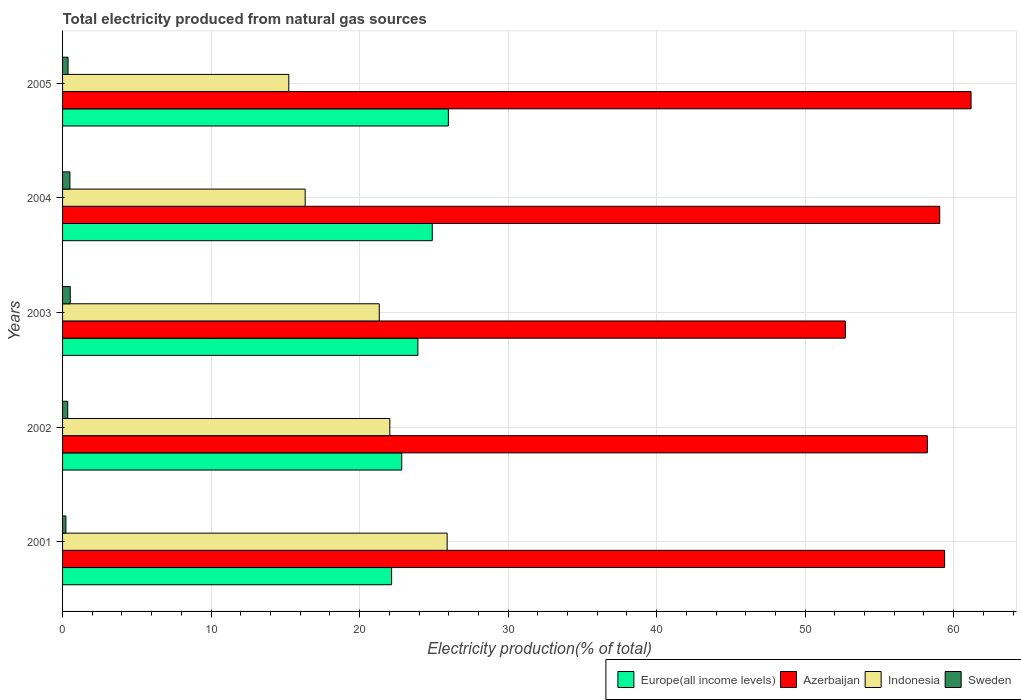How many groups of bars are there?
Give a very brief answer. 5. Are the number of bars on each tick of the Y-axis equal?
Your response must be concise. Yes. How many bars are there on the 1st tick from the top?
Your answer should be very brief. 4. How many bars are there on the 5th tick from the bottom?
Your answer should be compact. 4. In how many cases, is the number of bars for a given year not equal to the number of legend labels?
Give a very brief answer. 0. What is the total electricity produced in Europe(all income levels) in 2002?
Provide a succinct answer. 22.84. Across all years, what is the maximum total electricity produced in Sweden?
Your response must be concise. 0.52. Across all years, what is the minimum total electricity produced in Indonesia?
Make the answer very short. 15.23. What is the total total electricity produced in Europe(all income levels) in the graph?
Keep it short and to the point. 119.79. What is the difference between the total electricity produced in Indonesia in 2002 and that in 2005?
Ensure brevity in your answer.  6.8. What is the difference between the total electricity produced in Indonesia in 2004 and the total electricity produced in Europe(all income levels) in 2001?
Your answer should be very brief. -5.82. What is the average total electricity produced in Sweden per year?
Provide a short and direct response. 0.39. In the year 2003, what is the difference between the total electricity produced in Sweden and total electricity produced in Indonesia?
Offer a very short reply. -20.81. In how many years, is the total electricity produced in Indonesia greater than 40 %?
Make the answer very short. 0. What is the ratio of the total electricity produced in Sweden in 2002 to that in 2005?
Ensure brevity in your answer.  0.94. What is the difference between the highest and the second highest total electricity produced in Sweden?
Provide a succinct answer. 0.02. What is the difference between the highest and the lowest total electricity produced in Europe(all income levels)?
Ensure brevity in your answer.  3.82. In how many years, is the total electricity produced in Indonesia greater than the average total electricity produced in Indonesia taken over all years?
Your answer should be compact. 3. What does the 2nd bar from the top in 2004 represents?
Offer a very short reply. Indonesia. Are all the bars in the graph horizontal?
Ensure brevity in your answer.  Yes. Does the graph contain grids?
Keep it short and to the point. Yes. Where does the legend appear in the graph?
Keep it short and to the point. Bottom right. How many legend labels are there?
Provide a short and direct response. 4. What is the title of the graph?
Your response must be concise. Total electricity produced from natural gas sources. What is the Electricity production(% of total) in Europe(all income levels) in 2001?
Your response must be concise. 22.16. What is the Electricity production(% of total) of Azerbaijan in 2001?
Provide a short and direct response. 59.39. What is the Electricity production(% of total) in Indonesia in 2001?
Keep it short and to the point. 25.9. What is the Electricity production(% of total) of Sweden in 2001?
Provide a short and direct response. 0.22. What is the Electricity production(% of total) in Europe(all income levels) in 2002?
Your answer should be compact. 22.84. What is the Electricity production(% of total) of Azerbaijan in 2002?
Your answer should be compact. 58.23. What is the Electricity production(% of total) in Indonesia in 2002?
Your response must be concise. 22.03. What is the Electricity production(% of total) in Sweden in 2002?
Provide a short and direct response. 0.35. What is the Electricity production(% of total) of Europe(all income levels) in 2003?
Your answer should be compact. 23.92. What is the Electricity production(% of total) in Azerbaijan in 2003?
Give a very brief answer. 52.71. What is the Electricity production(% of total) of Indonesia in 2003?
Keep it short and to the point. 21.32. What is the Electricity production(% of total) of Sweden in 2003?
Make the answer very short. 0.52. What is the Electricity production(% of total) of Europe(all income levels) in 2004?
Make the answer very short. 24.89. What is the Electricity production(% of total) in Azerbaijan in 2004?
Keep it short and to the point. 59.06. What is the Electricity production(% of total) of Indonesia in 2004?
Offer a very short reply. 16.34. What is the Electricity production(% of total) in Sweden in 2004?
Keep it short and to the point. 0.49. What is the Electricity production(% of total) of Europe(all income levels) in 2005?
Keep it short and to the point. 25.98. What is the Electricity production(% of total) of Azerbaijan in 2005?
Provide a short and direct response. 61.17. What is the Electricity production(% of total) of Indonesia in 2005?
Keep it short and to the point. 15.23. What is the Electricity production(% of total) in Sweden in 2005?
Your answer should be compact. 0.37. Across all years, what is the maximum Electricity production(% of total) of Europe(all income levels)?
Offer a very short reply. 25.98. Across all years, what is the maximum Electricity production(% of total) in Azerbaijan?
Give a very brief answer. 61.17. Across all years, what is the maximum Electricity production(% of total) of Indonesia?
Ensure brevity in your answer.  25.9. Across all years, what is the maximum Electricity production(% of total) of Sweden?
Offer a very short reply. 0.52. Across all years, what is the minimum Electricity production(% of total) of Europe(all income levels)?
Your answer should be compact. 22.16. Across all years, what is the minimum Electricity production(% of total) of Azerbaijan?
Provide a short and direct response. 52.71. Across all years, what is the minimum Electricity production(% of total) of Indonesia?
Offer a terse response. 15.23. Across all years, what is the minimum Electricity production(% of total) in Sweden?
Give a very brief answer. 0.22. What is the total Electricity production(% of total) of Europe(all income levels) in the graph?
Offer a terse response. 119.79. What is the total Electricity production(% of total) in Azerbaijan in the graph?
Your answer should be compact. 290.55. What is the total Electricity production(% of total) of Indonesia in the graph?
Offer a very short reply. 100.82. What is the total Electricity production(% of total) of Sweden in the graph?
Keep it short and to the point. 1.95. What is the difference between the Electricity production(% of total) in Europe(all income levels) in 2001 and that in 2002?
Offer a very short reply. -0.68. What is the difference between the Electricity production(% of total) in Azerbaijan in 2001 and that in 2002?
Give a very brief answer. 1.16. What is the difference between the Electricity production(% of total) of Indonesia in 2001 and that in 2002?
Provide a short and direct response. 3.86. What is the difference between the Electricity production(% of total) of Sweden in 2001 and that in 2002?
Your response must be concise. -0.12. What is the difference between the Electricity production(% of total) of Europe(all income levels) in 2001 and that in 2003?
Offer a terse response. -1.77. What is the difference between the Electricity production(% of total) of Azerbaijan in 2001 and that in 2003?
Your answer should be very brief. 6.68. What is the difference between the Electricity production(% of total) of Indonesia in 2001 and that in 2003?
Your response must be concise. 4.57. What is the difference between the Electricity production(% of total) of Sweden in 2001 and that in 2003?
Provide a succinct answer. -0.29. What is the difference between the Electricity production(% of total) of Europe(all income levels) in 2001 and that in 2004?
Give a very brief answer. -2.74. What is the difference between the Electricity production(% of total) in Azerbaijan in 2001 and that in 2004?
Make the answer very short. 0.33. What is the difference between the Electricity production(% of total) in Indonesia in 2001 and that in 2004?
Provide a succinct answer. 9.56. What is the difference between the Electricity production(% of total) of Sweden in 2001 and that in 2004?
Offer a very short reply. -0.27. What is the difference between the Electricity production(% of total) of Europe(all income levels) in 2001 and that in 2005?
Offer a very short reply. -3.82. What is the difference between the Electricity production(% of total) of Azerbaijan in 2001 and that in 2005?
Provide a short and direct response. -1.78. What is the difference between the Electricity production(% of total) in Indonesia in 2001 and that in 2005?
Offer a terse response. 10.66. What is the difference between the Electricity production(% of total) of Sweden in 2001 and that in 2005?
Your answer should be compact. -0.15. What is the difference between the Electricity production(% of total) of Europe(all income levels) in 2002 and that in 2003?
Offer a very short reply. -1.09. What is the difference between the Electricity production(% of total) in Azerbaijan in 2002 and that in 2003?
Provide a short and direct response. 5.52. What is the difference between the Electricity production(% of total) in Indonesia in 2002 and that in 2003?
Your answer should be very brief. 0.71. What is the difference between the Electricity production(% of total) of Sweden in 2002 and that in 2003?
Offer a terse response. -0.17. What is the difference between the Electricity production(% of total) of Europe(all income levels) in 2002 and that in 2004?
Offer a very short reply. -2.05. What is the difference between the Electricity production(% of total) in Azerbaijan in 2002 and that in 2004?
Offer a very short reply. -0.83. What is the difference between the Electricity production(% of total) of Indonesia in 2002 and that in 2004?
Your answer should be very brief. 5.7. What is the difference between the Electricity production(% of total) in Sweden in 2002 and that in 2004?
Your answer should be compact. -0.15. What is the difference between the Electricity production(% of total) in Europe(all income levels) in 2002 and that in 2005?
Your answer should be compact. -3.14. What is the difference between the Electricity production(% of total) in Azerbaijan in 2002 and that in 2005?
Give a very brief answer. -2.94. What is the difference between the Electricity production(% of total) of Indonesia in 2002 and that in 2005?
Ensure brevity in your answer.  6.8. What is the difference between the Electricity production(% of total) in Sweden in 2002 and that in 2005?
Give a very brief answer. -0.02. What is the difference between the Electricity production(% of total) of Europe(all income levels) in 2003 and that in 2004?
Give a very brief answer. -0.97. What is the difference between the Electricity production(% of total) of Azerbaijan in 2003 and that in 2004?
Your answer should be compact. -6.35. What is the difference between the Electricity production(% of total) in Indonesia in 2003 and that in 2004?
Provide a succinct answer. 4.99. What is the difference between the Electricity production(% of total) in Sweden in 2003 and that in 2004?
Give a very brief answer. 0.02. What is the difference between the Electricity production(% of total) in Europe(all income levels) in 2003 and that in 2005?
Provide a short and direct response. -2.05. What is the difference between the Electricity production(% of total) in Azerbaijan in 2003 and that in 2005?
Your answer should be very brief. -8.46. What is the difference between the Electricity production(% of total) in Indonesia in 2003 and that in 2005?
Offer a terse response. 6.09. What is the difference between the Electricity production(% of total) in Sweden in 2003 and that in 2005?
Offer a very short reply. 0.15. What is the difference between the Electricity production(% of total) of Europe(all income levels) in 2004 and that in 2005?
Ensure brevity in your answer.  -1.08. What is the difference between the Electricity production(% of total) in Azerbaijan in 2004 and that in 2005?
Your answer should be compact. -2.11. What is the difference between the Electricity production(% of total) in Indonesia in 2004 and that in 2005?
Keep it short and to the point. 1.1. What is the difference between the Electricity production(% of total) of Sweden in 2004 and that in 2005?
Make the answer very short. 0.12. What is the difference between the Electricity production(% of total) of Europe(all income levels) in 2001 and the Electricity production(% of total) of Azerbaijan in 2002?
Your answer should be compact. -36.07. What is the difference between the Electricity production(% of total) in Europe(all income levels) in 2001 and the Electricity production(% of total) in Indonesia in 2002?
Your response must be concise. 0.12. What is the difference between the Electricity production(% of total) in Europe(all income levels) in 2001 and the Electricity production(% of total) in Sweden in 2002?
Offer a terse response. 21.81. What is the difference between the Electricity production(% of total) in Azerbaijan in 2001 and the Electricity production(% of total) in Indonesia in 2002?
Ensure brevity in your answer.  37.35. What is the difference between the Electricity production(% of total) of Azerbaijan in 2001 and the Electricity production(% of total) of Sweden in 2002?
Provide a succinct answer. 59.04. What is the difference between the Electricity production(% of total) in Indonesia in 2001 and the Electricity production(% of total) in Sweden in 2002?
Provide a succinct answer. 25.55. What is the difference between the Electricity production(% of total) of Europe(all income levels) in 2001 and the Electricity production(% of total) of Azerbaijan in 2003?
Ensure brevity in your answer.  -30.55. What is the difference between the Electricity production(% of total) in Europe(all income levels) in 2001 and the Electricity production(% of total) in Indonesia in 2003?
Keep it short and to the point. 0.83. What is the difference between the Electricity production(% of total) in Europe(all income levels) in 2001 and the Electricity production(% of total) in Sweden in 2003?
Make the answer very short. 21.64. What is the difference between the Electricity production(% of total) of Azerbaijan in 2001 and the Electricity production(% of total) of Indonesia in 2003?
Provide a short and direct response. 38.06. What is the difference between the Electricity production(% of total) in Azerbaijan in 2001 and the Electricity production(% of total) in Sweden in 2003?
Provide a short and direct response. 58.87. What is the difference between the Electricity production(% of total) of Indonesia in 2001 and the Electricity production(% of total) of Sweden in 2003?
Provide a short and direct response. 25.38. What is the difference between the Electricity production(% of total) of Europe(all income levels) in 2001 and the Electricity production(% of total) of Azerbaijan in 2004?
Your response must be concise. -36.9. What is the difference between the Electricity production(% of total) in Europe(all income levels) in 2001 and the Electricity production(% of total) in Indonesia in 2004?
Your response must be concise. 5.82. What is the difference between the Electricity production(% of total) in Europe(all income levels) in 2001 and the Electricity production(% of total) in Sweden in 2004?
Offer a very short reply. 21.66. What is the difference between the Electricity production(% of total) of Azerbaijan in 2001 and the Electricity production(% of total) of Indonesia in 2004?
Make the answer very short. 43.05. What is the difference between the Electricity production(% of total) in Azerbaijan in 2001 and the Electricity production(% of total) in Sweden in 2004?
Provide a short and direct response. 58.89. What is the difference between the Electricity production(% of total) of Indonesia in 2001 and the Electricity production(% of total) of Sweden in 2004?
Provide a short and direct response. 25.4. What is the difference between the Electricity production(% of total) in Europe(all income levels) in 2001 and the Electricity production(% of total) in Azerbaijan in 2005?
Keep it short and to the point. -39.02. What is the difference between the Electricity production(% of total) in Europe(all income levels) in 2001 and the Electricity production(% of total) in Indonesia in 2005?
Your answer should be very brief. 6.92. What is the difference between the Electricity production(% of total) in Europe(all income levels) in 2001 and the Electricity production(% of total) in Sweden in 2005?
Your answer should be compact. 21.79. What is the difference between the Electricity production(% of total) of Azerbaijan in 2001 and the Electricity production(% of total) of Indonesia in 2005?
Give a very brief answer. 44.16. What is the difference between the Electricity production(% of total) in Azerbaijan in 2001 and the Electricity production(% of total) in Sweden in 2005?
Keep it short and to the point. 59.02. What is the difference between the Electricity production(% of total) of Indonesia in 2001 and the Electricity production(% of total) of Sweden in 2005?
Provide a short and direct response. 25.53. What is the difference between the Electricity production(% of total) of Europe(all income levels) in 2002 and the Electricity production(% of total) of Azerbaijan in 2003?
Your answer should be very brief. -29.87. What is the difference between the Electricity production(% of total) of Europe(all income levels) in 2002 and the Electricity production(% of total) of Indonesia in 2003?
Your answer should be very brief. 1.51. What is the difference between the Electricity production(% of total) of Europe(all income levels) in 2002 and the Electricity production(% of total) of Sweden in 2003?
Your answer should be compact. 22.32. What is the difference between the Electricity production(% of total) of Azerbaijan in 2002 and the Electricity production(% of total) of Indonesia in 2003?
Provide a succinct answer. 36.9. What is the difference between the Electricity production(% of total) of Azerbaijan in 2002 and the Electricity production(% of total) of Sweden in 2003?
Keep it short and to the point. 57.71. What is the difference between the Electricity production(% of total) of Indonesia in 2002 and the Electricity production(% of total) of Sweden in 2003?
Offer a terse response. 21.52. What is the difference between the Electricity production(% of total) of Europe(all income levels) in 2002 and the Electricity production(% of total) of Azerbaijan in 2004?
Offer a very short reply. -36.22. What is the difference between the Electricity production(% of total) in Europe(all income levels) in 2002 and the Electricity production(% of total) in Indonesia in 2004?
Make the answer very short. 6.5. What is the difference between the Electricity production(% of total) in Europe(all income levels) in 2002 and the Electricity production(% of total) in Sweden in 2004?
Your answer should be compact. 22.34. What is the difference between the Electricity production(% of total) in Azerbaijan in 2002 and the Electricity production(% of total) in Indonesia in 2004?
Your answer should be very brief. 41.89. What is the difference between the Electricity production(% of total) in Azerbaijan in 2002 and the Electricity production(% of total) in Sweden in 2004?
Ensure brevity in your answer.  57.73. What is the difference between the Electricity production(% of total) in Indonesia in 2002 and the Electricity production(% of total) in Sweden in 2004?
Make the answer very short. 21.54. What is the difference between the Electricity production(% of total) in Europe(all income levels) in 2002 and the Electricity production(% of total) in Azerbaijan in 2005?
Keep it short and to the point. -38.33. What is the difference between the Electricity production(% of total) of Europe(all income levels) in 2002 and the Electricity production(% of total) of Indonesia in 2005?
Ensure brevity in your answer.  7.6. What is the difference between the Electricity production(% of total) in Europe(all income levels) in 2002 and the Electricity production(% of total) in Sweden in 2005?
Make the answer very short. 22.47. What is the difference between the Electricity production(% of total) of Azerbaijan in 2002 and the Electricity production(% of total) of Indonesia in 2005?
Your response must be concise. 42.99. What is the difference between the Electricity production(% of total) in Azerbaijan in 2002 and the Electricity production(% of total) in Sweden in 2005?
Make the answer very short. 57.86. What is the difference between the Electricity production(% of total) in Indonesia in 2002 and the Electricity production(% of total) in Sweden in 2005?
Offer a terse response. 21.66. What is the difference between the Electricity production(% of total) in Europe(all income levels) in 2003 and the Electricity production(% of total) in Azerbaijan in 2004?
Ensure brevity in your answer.  -35.14. What is the difference between the Electricity production(% of total) in Europe(all income levels) in 2003 and the Electricity production(% of total) in Indonesia in 2004?
Give a very brief answer. 7.59. What is the difference between the Electricity production(% of total) in Europe(all income levels) in 2003 and the Electricity production(% of total) in Sweden in 2004?
Ensure brevity in your answer.  23.43. What is the difference between the Electricity production(% of total) in Azerbaijan in 2003 and the Electricity production(% of total) in Indonesia in 2004?
Make the answer very short. 36.37. What is the difference between the Electricity production(% of total) of Azerbaijan in 2003 and the Electricity production(% of total) of Sweden in 2004?
Ensure brevity in your answer.  52.21. What is the difference between the Electricity production(% of total) in Indonesia in 2003 and the Electricity production(% of total) in Sweden in 2004?
Make the answer very short. 20.83. What is the difference between the Electricity production(% of total) in Europe(all income levels) in 2003 and the Electricity production(% of total) in Azerbaijan in 2005?
Keep it short and to the point. -37.25. What is the difference between the Electricity production(% of total) in Europe(all income levels) in 2003 and the Electricity production(% of total) in Indonesia in 2005?
Offer a terse response. 8.69. What is the difference between the Electricity production(% of total) in Europe(all income levels) in 2003 and the Electricity production(% of total) in Sweden in 2005?
Offer a terse response. 23.55. What is the difference between the Electricity production(% of total) in Azerbaijan in 2003 and the Electricity production(% of total) in Indonesia in 2005?
Ensure brevity in your answer.  37.47. What is the difference between the Electricity production(% of total) in Azerbaijan in 2003 and the Electricity production(% of total) in Sweden in 2005?
Give a very brief answer. 52.34. What is the difference between the Electricity production(% of total) of Indonesia in 2003 and the Electricity production(% of total) of Sweden in 2005?
Your response must be concise. 20.95. What is the difference between the Electricity production(% of total) in Europe(all income levels) in 2004 and the Electricity production(% of total) in Azerbaijan in 2005?
Give a very brief answer. -36.28. What is the difference between the Electricity production(% of total) of Europe(all income levels) in 2004 and the Electricity production(% of total) of Indonesia in 2005?
Offer a terse response. 9.66. What is the difference between the Electricity production(% of total) of Europe(all income levels) in 2004 and the Electricity production(% of total) of Sweden in 2005?
Your answer should be very brief. 24.52. What is the difference between the Electricity production(% of total) of Azerbaijan in 2004 and the Electricity production(% of total) of Indonesia in 2005?
Offer a terse response. 43.83. What is the difference between the Electricity production(% of total) in Azerbaijan in 2004 and the Electricity production(% of total) in Sweden in 2005?
Keep it short and to the point. 58.69. What is the difference between the Electricity production(% of total) of Indonesia in 2004 and the Electricity production(% of total) of Sweden in 2005?
Give a very brief answer. 15.97. What is the average Electricity production(% of total) in Europe(all income levels) per year?
Offer a very short reply. 23.96. What is the average Electricity production(% of total) of Azerbaijan per year?
Keep it short and to the point. 58.11. What is the average Electricity production(% of total) of Indonesia per year?
Provide a short and direct response. 20.16. What is the average Electricity production(% of total) of Sweden per year?
Provide a succinct answer. 0.39. In the year 2001, what is the difference between the Electricity production(% of total) in Europe(all income levels) and Electricity production(% of total) in Azerbaijan?
Make the answer very short. -37.23. In the year 2001, what is the difference between the Electricity production(% of total) of Europe(all income levels) and Electricity production(% of total) of Indonesia?
Your response must be concise. -3.74. In the year 2001, what is the difference between the Electricity production(% of total) of Europe(all income levels) and Electricity production(% of total) of Sweden?
Ensure brevity in your answer.  21.93. In the year 2001, what is the difference between the Electricity production(% of total) of Azerbaijan and Electricity production(% of total) of Indonesia?
Make the answer very short. 33.49. In the year 2001, what is the difference between the Electricity production(% of total) of Azerbaijan and Electricity production(% of total) of Sweden?
Provide a succinct answer. 59.17. In the year 2001, what is the difference between the Electricity production(% of total) of Indonesia and Electricity production(% of total) of Sweden?
Ensure brevity in your answer.  25.67. In the year 2002, what is the difference between the Electricity production(% of total) of Europe(all income levels) and Electricity production(% of total) of Azerbaijan?
Offer a very short reply. -35.39. In the year 2002, what is the difference between the Electricity production(% of total) in Europe(all income levels) and Electricity production(% of total) in Indonesia?
Offer a terse response. 0.8. In the year 2002, what is the difference between the Electricity production(% of total) of Europe(all income levels) and Electricity production(% of total) of Sweden?
Your answer should be very brief. 22.49. In the year 2002, what is the difference between the Electricity production(% of total) in Azerbaijan and Electricity production(% of total) in Indonesia?
Make the answer very short. 36.19. In the year 2002, what is the difference between the Electricity production(% of total) of Azerbaijan and Electricity production(% of total) of Sweden?
Your response must be concise. 57.88. In the year 2002, what is the difference between the Electricity production(% of total) of Indonesia and Electricity production(% of total) of Sweden?
Your response must be concise. 21.69. In the year 2003, what is the difference between the Electricity production(% of total) in Europe(all income levels) and Electricity production(% of total) in Azerbaijan?
Provide a short and direct response. -28.78. In the year 2003, what is the difference between the Electricity production(% of total) in Europe(all income levels) and Electricity production(% of total) in Indonesia?
Keep it short and to the point. 2.6. In the year 2003, what is the difference between the Electricity production(% of total) of Europe(all income levels) and Electricity production(% of total) of Sweden?
Ensure brevity in your answer.  23.41. In the year 2003, what is the difference between the Electricity production(% of total) in Azerbaijan and Electricity production(% of total) in Indonesia?
Keep it short and to the point. 31.38. In the year 2003, what is the difference between the Electricity production(% of total) of Azerbaijan and Electricity production(% of total) of Sweden?
Provide a succinct answer. 52.19. In the year 2003, what is the difference between the Electricity production(% of total) of Indonesia and Electricity production(% of total) of Sweden?
Make the answer very short. 20.81. In the year 2004, what is the difference between the Electricity production(% of total) in Europe(all income levels) and Electricity production(% of total) in Azerbaijan?
Your answer should be compact. -34.17. In the year 2004, what is the difference between the Electricity production(% of total) of Europe(all income levels) and Electricity production(% of total) of Indonesia?
Your answer should be very brief. 8.56. In the year 2004, what is the difference between the Electricity production(% of total) in Europe(all income levels) and Electricity production(% of total) in Sweden?
Offer a terse response. 24.4. In the year 2004, what is the difference between the Electricity production(% of total) of Azerbaijan and Electricity production(% of total) of Indonesia?
Give a very brief answer. 42.72. In the year 2004, what is the difference between the Electricity production(% of total) of Azerbaijan and Electricity production(% of total) of Sweden?
Give a very brief answer. 58.57. In the year 2004, what is the difference between the Electricity production(% of total) of Indonesia and Electricity production(% of total) of Sweden?
Provide a short and direct response. 15.84. In the year 2005, what is the difference between the Electricity production(% of total) in Europe(all income levels) and Electricity production(% of total) in Azerbaijan?
Make the answer very short. -35.19. In the year 2005, what is the difference between the Electricity production(% of total) of Europe(all income levels) and Electricity production(% of total) of Indonesia?
Make the answer very short. 10.74. In the year 2005, what is the difference between the Electricity production(% of total) of Europe(all income levels) and Electricity production(% of total) of Sweden?
Offer a terse response. 25.61. In the year 2005, what is the difference between the Electricity production(% of total) in Azerbaijan and Electricity production(% of total) in Indonesia?
Give a very brief answer. 45.94. In the year 2005, what is the difference between the Electricity production(% of total) in Azerbaijan and Electricity production(% of total) in Sweden?
Offer a terse response. 60.8. In the year 2005, what is the difference between the Electricity production(% of total) in Indonesia and Electricity production(% of total) in Sweden?
Your response must be concise. 14.86. What is the ratio of the Electricity production(% of total) in Europe(all income levels) in 2001 to that in 2002?
Keep it short and to the point. 0.97. What is the ratio of the Electricity production(% of total) of Indonesia in 2001 to that in 2002?
Make the answer very short. 1.18. What is the ratio of the Electricity production(% of total) of Sweden in 2001 to that in 2002?
Ensure brevity in your answer.  0.64. What is the ratio of the Electricity production(% of total) in Europe(all income levels) in 2001 to that in 2003?
Provide a short and direct response. 0.93. What is the ratio of the Electricity production(% of total) of Azerbaijan in 2001 to that in 2003?
Make the answer very short. 1.13. What is the ratio of the Electricity production(% of total) in Indonesia in 2001 to that in 2003?
Your answer should be very brief. 1.21. What is the ratio of the Electricity production(% of total) in Sweden in 2001 to that in 2003?
Offer a very short reply. 0.43. What is the ratio of the Electricity production(% of total) of Europe(all income levels) in 2001 to that in 2004?
Provide a succinct answer. 0.89. What is the ratio of the Electricity production(% of total) of Azerbaijan in 2001 to that in 2004?
Ensure brevity in your answer.  1.01. What is the ratio of the Electricity production(% of total) of Indonesia in 2001 to that in 2004?
Offer a very short reply. 1.59. What is the ratio of the Electricity production(% of total) in Sweden in 2001 to that in 2004?
Make the answer very short. 0.45. What is the ratio of the Electricity production(% of total) in Europe(all income levels) in 2001 to that in 2005?
Your response must be concise. 0.85. What is the ratio of the Electricity production(% of total) of Azerbaijan in 2001 to that in 2005?
Offer a terse response. 0.97. What is the ratio of the Electricity production(% of total) in Indonesia in 2001 to that in 2005?
Give a very brief answer. 1.7. What is the ratio of the Electricity production(% of total) of Sweden in 2001 to that in 2005?
Your response must be concise. 0.6. What is the ratio of the Electricity production(% of total) in Europe(all income levels) in 2002 to that in 2003?
Your answer should be very brief. 0.95. What is the ratio of the Electricity production(% of total) in Azerbaijan in 2002 to that in 2003?
Provide a short and direct response. 1.1. What is the ratio of the Electricity production(% of total) of Indonesia in 2002 to that in 2003?
Provide a succinct answer. 1.03. What is the ratio of the Electricity production(% of total) in Sweden in 2002 to that in 2003?
Provide a succinct answer. 0.67. What is the ratio of the Electricity production(% of total) of Europe(all income levels) in 2002 to that in 2004?
Keep it short and to the point. 0.92. What is the ratio of the Electricity production(% of total) of Azerbaijan in 2002 to that in 2004?
Give a very brief answer. 0.99. What is the ratio of the Electricity production(% of total) of Indonesia in 2002 to that in 2004?
Keep it short and to the point. 1.35. What is the ratio of the Electricity production(% of total) in Sweden in 2002 to that in 2004?
Give a very brief answer. 0.7. What is the ratio of the Electricity production(% of total) in Europe(all income levels) in 2002 to that in 2005?
Keep it short and to the point. 0.88. What is the ratio of the Electricity production(% of total) of Azerbaijan in 2002 to that in 2005?
Keep it short and to the point. 0.95. What is the ratio of the Electricity production(% of total) of Indonesia in 2002 to that in 2005?
Offer a terse response. 1.45. What is the ratio of the Electricity production(% of total) of Sweden in 2002 to that in 2005?
Provide a succinct answer. 0.94. What is the ratio of the Electricity production(% of total) of Europe(all income levels) in 2003 to that in 2004?
Your response must be concise. 0.96. What is the ratio of the Electricity production(% of total) in Azerbaijan in 2003 to that in 2004?
Ensure brevity in your answer.  0.89. What is the ratio of the Electricity production(% of total) of Indonesia in 2003 to that in 2004?
Your response must be concise. 1.31. What is the ratio of the Electricity production(% of total) in Sweden in 2003 to that in 2004?
Make the answer very short. 1.05. What is the ratio of the Electricity production(% of total) of Europe(all income levels) in 2003 to that in 2005?
Ensure brevity in your answer.  0.92. What is the ratio of the Electricity production(% of total) of Azerbaijan in 2003 to that in 2005?
Make the answer very short. 0.86. What is the ratio of the Electricity production(% of total) of Indonesia in 2003 to that in 2005?
Ensure brevity in your answer.  1.4. What is the ratio of the Electricity production(% of total) in Sweden in 2003 to that in 2005?
Ensure brevity in your answer.  1.4. What is the ratio of the Electricity production(% of total) of Europe(all income levels) in 2004 to that in 2005?
Offer a very short reply. 0.96. What is the ratio of the Electricity production(% of total) of Azerbaijan in 2004 to that in 2005?
Your answer should be compact. 0.97. What is the ratio of the Electricity production(% of total) of Indonesia in 2004 to that in 2005?
Your response must be concise. 1.07. What is the ratio of the Electricity production(% of total) in Sweden in 2004 to that in 2005?
Keep it short and to the point. 1.34. What is the difference between the highest and the second highest Electricity production(% of total) of Europe(all income levels)?
Give a very brief answer. 1.08. What is the difference between the highest and the second highest Electricity production(% of total) of Azerbaijan?
Offer a terse response. 1.78. What is the difference between the highest and the second highest Electricity production(% of total) of Indonesia?
Your answer should be compact. 3.86. What is the difference between the highest and the second highest Electricity production(% of total) in Sweden?
Provide a succinct answer. 0.02. What is the difference between the highest and the lowest Electricity production(% of total) of Europe(all income levels)?
Ensure brevity in your answer.  3.82. What is the difference between the highest and the lowest Electricity production(% of total) in Azerbaijan?
Your response must be concise. 8.46. What is the difference between the highest and the lowest Electricity production(% of total) of Indonesia?
Your answer should be very brief. 10.66. What is the difference between the highest and the lowest Electricity production(% of total) of Sweden?
Provide a short and direct response. 0.29. 